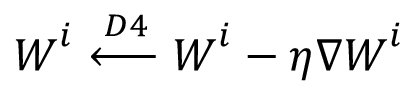<formula> <loc_0><loc_0><loc_500><loc_500>W ^ { i } \xleftarrow { D 4 } W ^ { i } - \eta \nabla W ^ { i }</formula> 